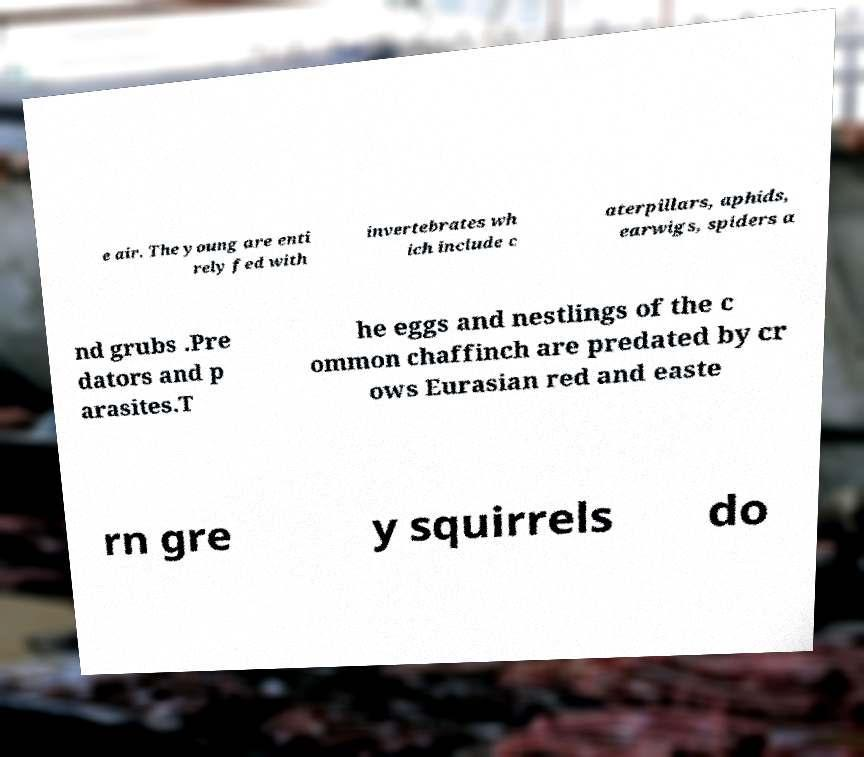Could you assist in decoding the text presented in this image and type it out clearly? e air. The young are enti rely fed with invertebrates wh ich include c aterpillars, aphids, earwigs, spiders a nd grubs .Pre dators and p arasites.T he eggs and nestlings of the c ommon chaffinch are predated by cr ows Eurasian red and easte rn gre y squirrels do 